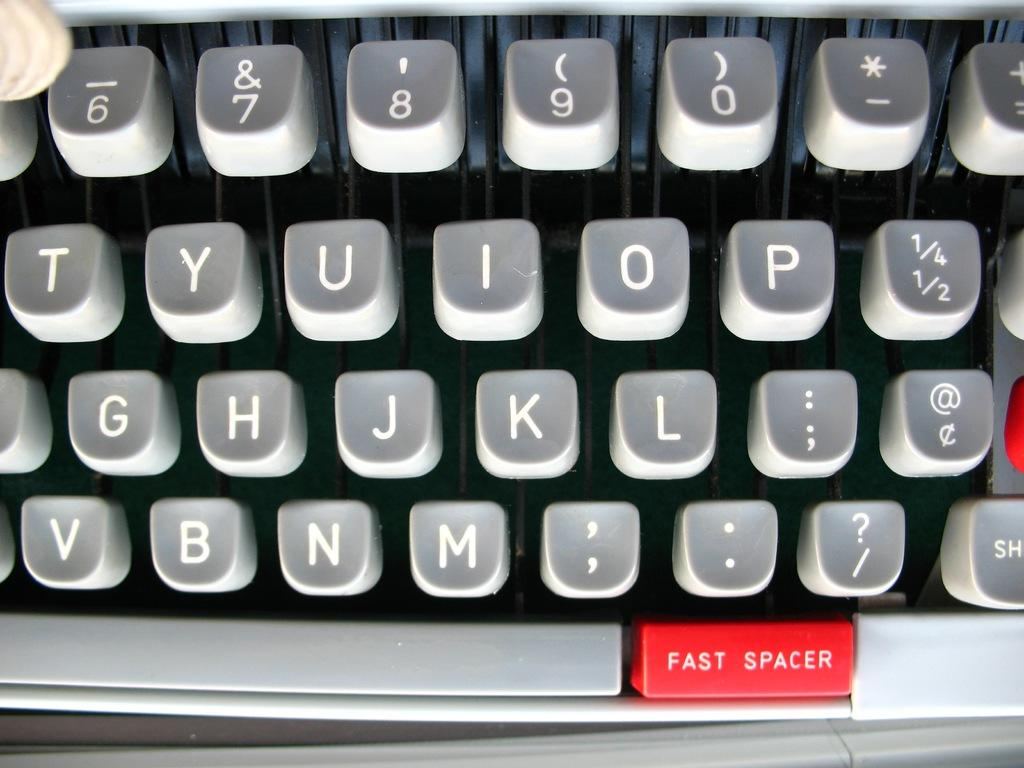<image>
Share a concise interpretation of the image provided. Gray keyboard with a red key that says Fast Spacer. 